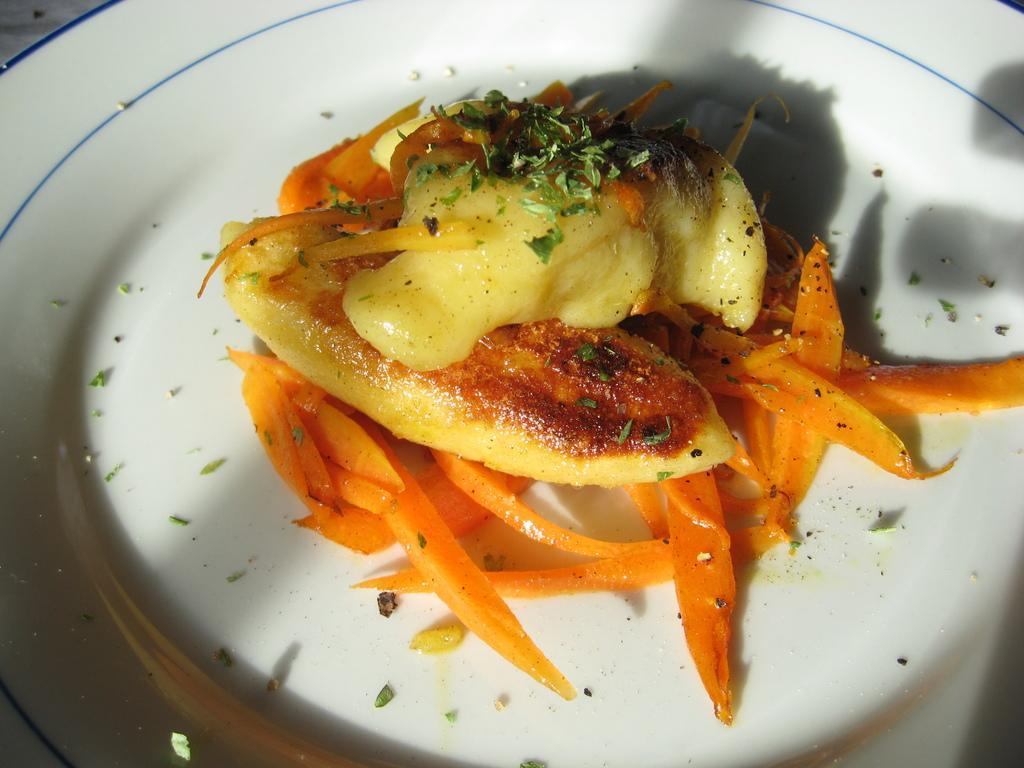In one or two sentences, can you explain what this image depicts? In this picture we can see food items on a plate. 